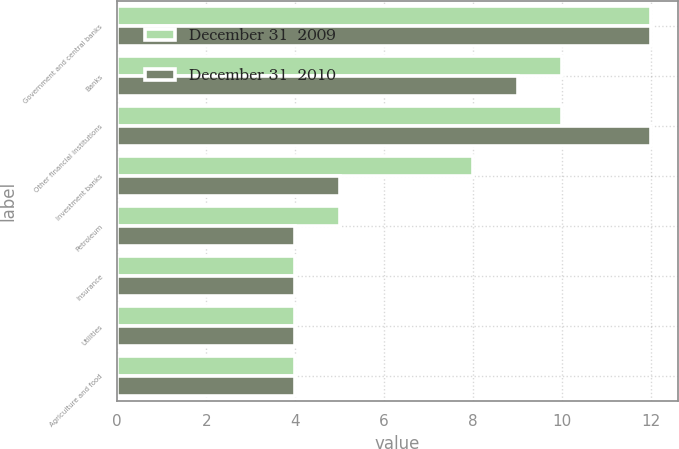Convert chart to OTSL. <chart><loc_0><loc_0><loc_500><loc_500><stacked_bar_chart><ecel><fcel>Government and central banks<fcel>Banks<fcel>Other financial institutions<fcel>Investment banks<fcel>Petroleum<fcel>Insurance<fcel>Utilities<fcel>Agriculture and food<nl><fcel>December 31  2009<fcel>12<fcel>10<fcel>10<fcel>8<fcel>5<fcel>4<fcel>4<fcel>4<nl><fcel>December 31  2010<fcel>12<fcel>9<fcel>12<fcel>5<fcel>4<fcel>4<fcel>4<fcel>4<nl></chart> 